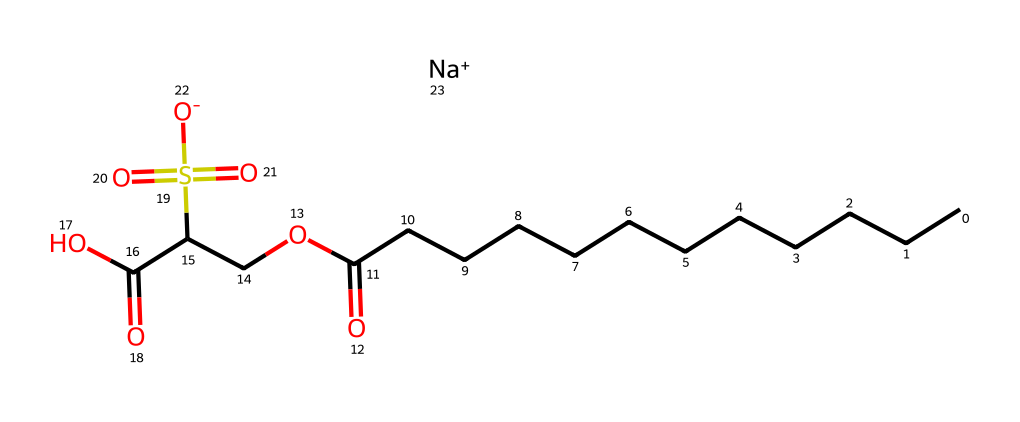What is the name of this chemical? The structure contains the elements and arrangement that correspond to sodium cocoyl isethionate, typically known as a cleansing agent found in makeup removers.
Answer: sodium cocoyl isethionate How many carbon atoms are present in this molecule? By counting the 'C' atoms in the structure, there are 15 carbon atoms displayed in the alkyl chain and the backbone of the molecule.
Answer: 15 What functional group can be identified in this chemical? The structure shows the presence of a sulfonate group (as indicated by 'S(=O)(=O)[O-]'), which is characteristic of many surfactants including detergents.
Answer: sulfonate What is the charge of the sodium ion in this molecule? The '[Na+]' notation at the end of the SMILES indicates that the sodium ion carries a positive charge represented by the '+' sign.
Answer: positive How does the length of the carbon chain affect the properties of this chemical? The long carbon chain (C12) establishes hydrophobic properties, which are crucial for emulsifying oils and dirt, enable this compound's efficacy as a detergent.
Answer: hydrophobic properties What role does the isethionate part of the molecule play in its function? The isethionate group ('OCC(C(O)=O)') contributes to the hydrophilic character, allowing it to mix with water and promote cleansing by attracting water molecules.
Answer: hydrophilic character 